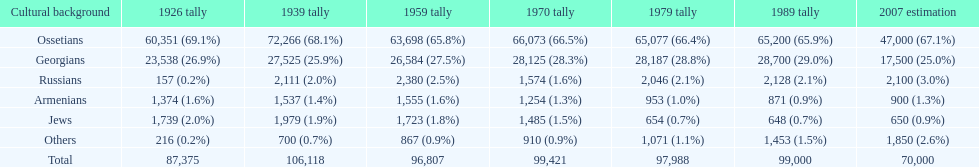Parse the table in full. {'header': ['Cultural background', '1926 tally', '1939 tally', '1959 tally', '1970 tally', '1979 tally', '1989 tally', '2007 estimation'], 'rows': [['Ossetians', '60,351 (69.1%)', '72,266 (68.1%)', '63,698 (65.8%)', '66,073 (66.5%)', '65,077 (66.4%)', '65,200 (65.9%)', '47,000 (67.1%)'], ['Georgians', '23,538 (26.9%)', '27,525 (25.9%)', '26,584 (27.5%)', '28,125 (28.3%)', '28,187 (28.8%)', '28,700 (29.0%)', '17,500 (25.0%)'], ['Russians', '157 (0.2%)', '2,111 (2.0%)', '2,380 (2.5%)', '1,574 (1.6%)', '2,046 (2.1%)', '2,128 (2.1%)', '2,100 (3.0%)'], ['Armenians', '1,374 (1.6%)', '1,537 (1.4%)', '1,555 (1.6%)', '1,254 (1.3%)', '953 (1.0%)', '871 (0.9%)', '900 (1.3%)'], ['Jews', '1,739 (2.0%)', '1,979 (1.9%)', '1,723 (1.8%)', '1,485 (1.5%)', '654 (0.7%)', '648 (0.7%)', '650 (0.9%)'], ['Others', '216 (0.2%)', '700 (0.7%)', '867 (0.9%)', '910 (0.9%)', '1,071 (1.1%)', '1,453 (1.5%)', '1,850 (2.6%)'], ['Total', '87,375', '106,118', '96,807', '99,421', '97,988', '99,000', '70,000']]} How many russians lived in south ossetia in 1970? 1,574. 